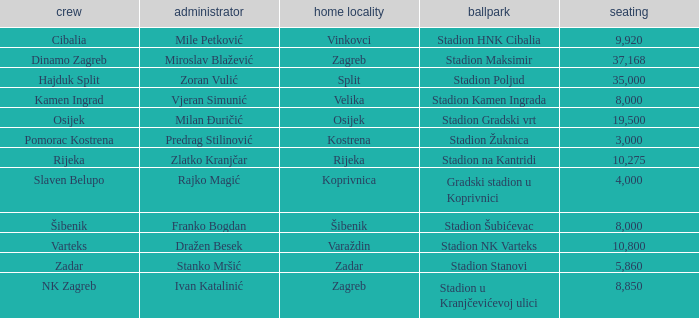What team that has a Home city of Zadar? Zadar. 